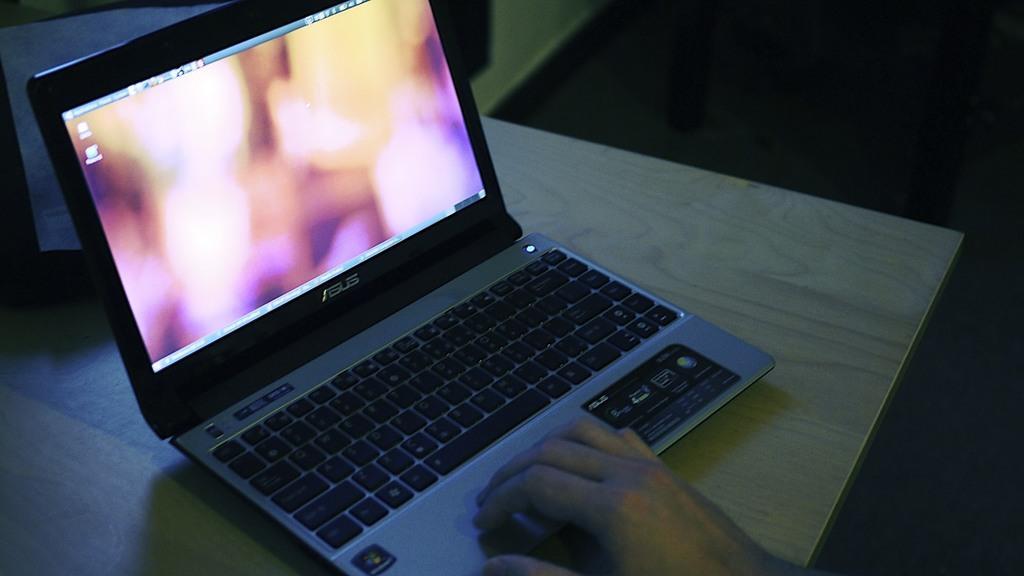Could you give a brief overview of what you see in this image? Here I can see a laptop is placed on a table. At the bottom, I can see a person's hand using the laptop. The background is dark. 